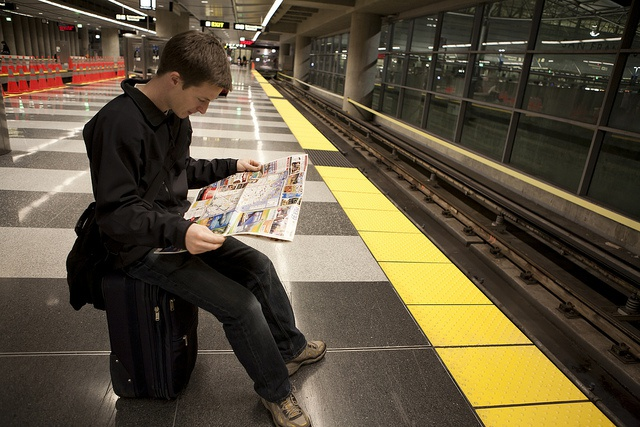Describe the objects in this image and their specific colors. I can see people in black, maroon, and gray tones, suitcase in black and gray tones, people in black and gray tones, and people in black and purple tones in this image. 